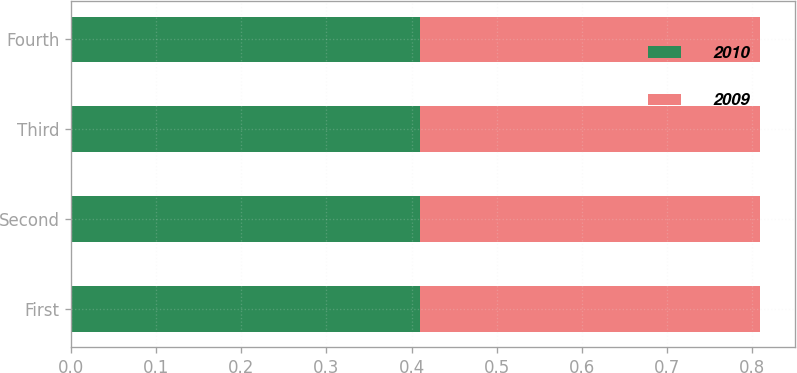Convert chart. <chart><loc_0><loc_0><loc_500><loc_500><stacked_bar_chart><ecel><fcel>First<fcel>Second<fcel>Third<fcel>Fourth<nl><fcel>2010<fcel>0.41<fcel>0.41<fcel>0.41<fcel>0.41<nl><fcel>2009<fcel>0.4<fcel>0.4<fcel>0.4<fcel>0.4<nl></chart> 